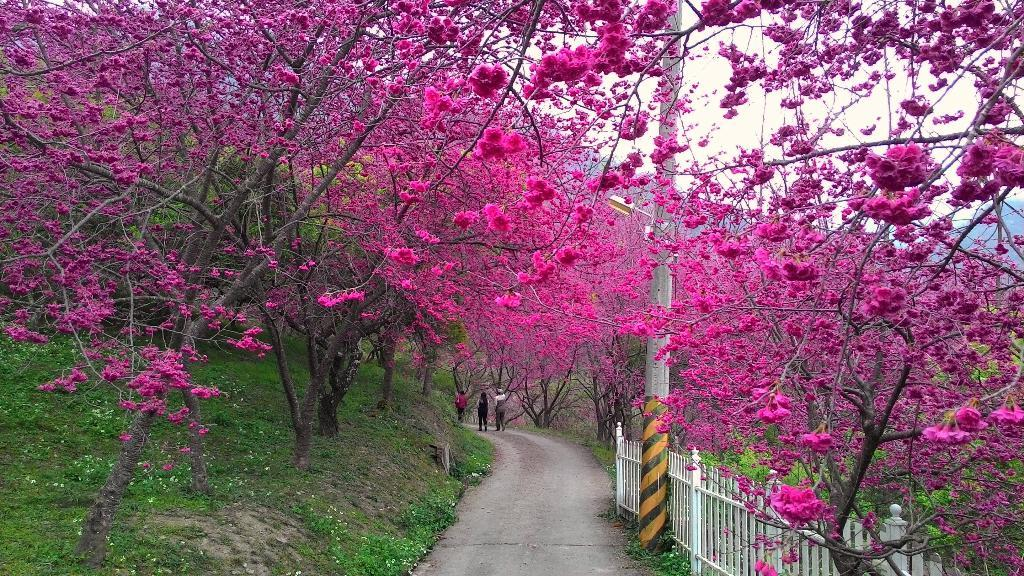What is the main feature in the center of the image? There is a lane in the center of the image. What is located beside the lane? There is a fence and a pole beside the lane. What can be seen on either side of the lane? There are trees with pink flowers on either side of the lane. What type of jam is being spread on the cracker in the image? There is no jam or cracker present in the image; it features a lane with a fence, pole, and trees with pink flowers. 